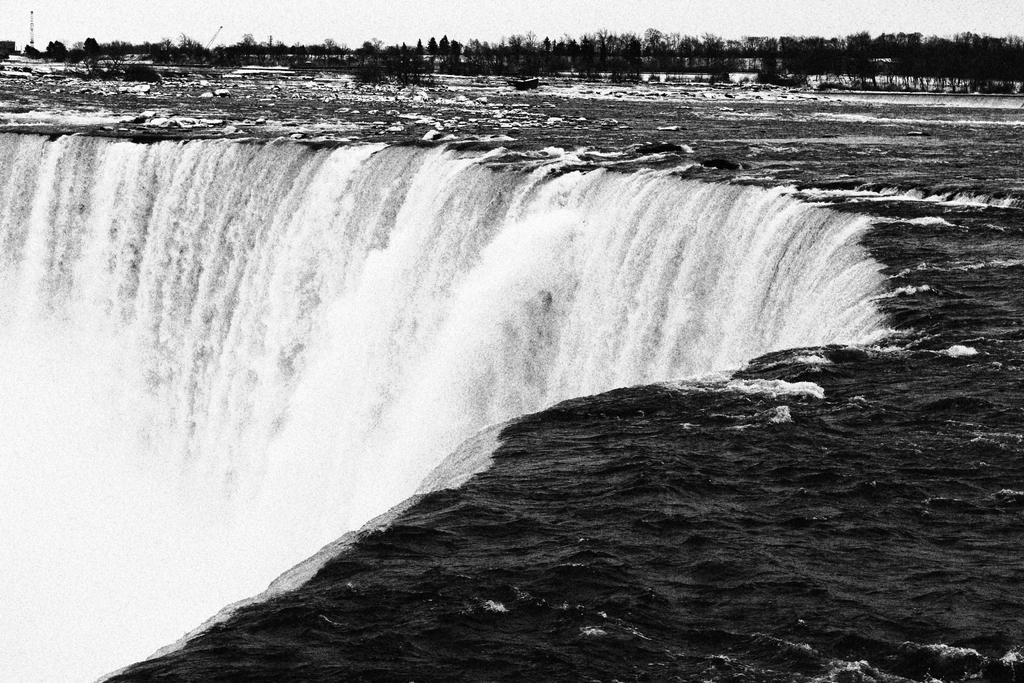What is the main subject of the image? The main subject of the image is a waterfall. Where is the waterfall located in the image? The waterfall is in the center of the image. What can be seen in the background of the image? There are trees in the background of the image. What type of trousers are the trees wearing in the image? Trees do not wear trousers, as they are plants and not human beings. 